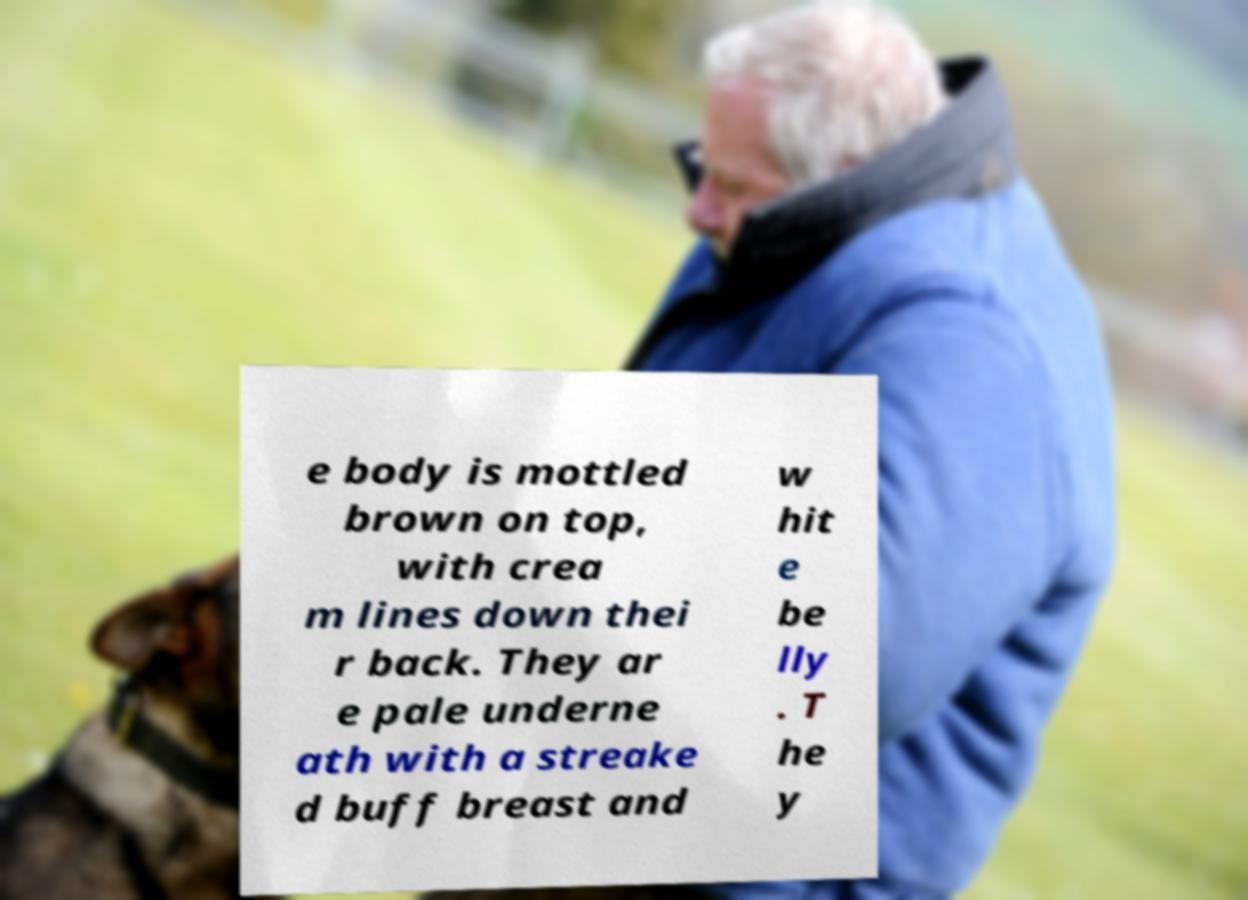I need the written content from this picture converted into text. Can you do that? e body is mottled brown on top, with crea m lines down thei r back. They ar e pale underne ath with a streake d buff breast and w hit e be lly . T he y 